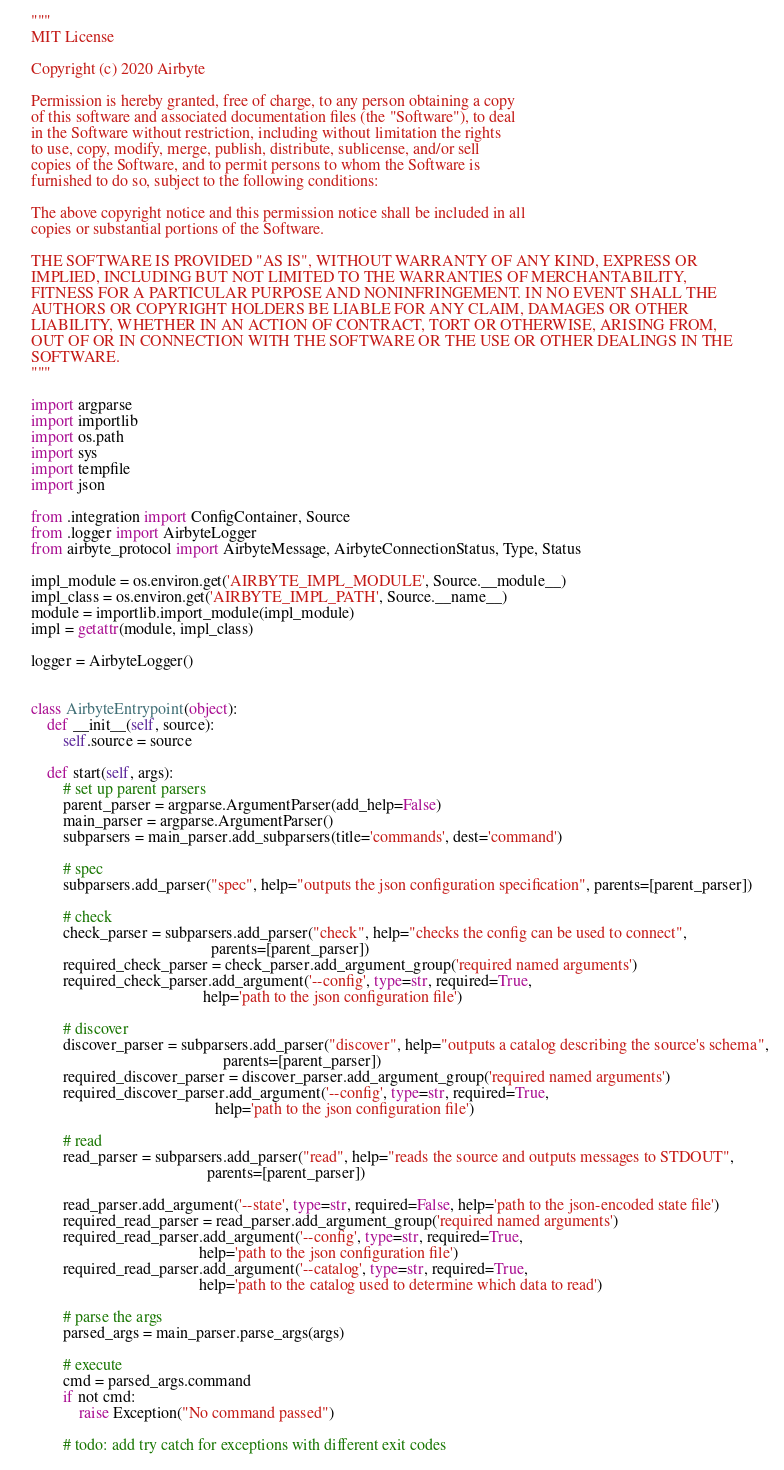<code> <loc_0><loc_0><loc_500><loc_500><_Python_>"""
MIT License

Copyright (c) 2020 Airbyte

Permission is hereby granted, free of charge, to any person obtaining a copy
of this software and associated documentation files (the "Software"), to deal
in the Software without restriction, including without limitation the rights
to use, copy, modify, merge, publish, distribute, sublicense, and/or sell
copies of the Software, and to permit persons to whom the Software is
furnished to do so, subject to the following conditions:

The above copyright notice and this permission notice shall be included in all
copies or substantial portions of the Software.

THE SOFTWARE IS PROVIDED "AS IS", WITHOUT WARRANTY OF ANY KIND, EXPRESS OR
IMPLIED, INCLUDING BUT NOT LIMITED TO THE WARRANTIES OF MERCHANTABILITY,
FITNESS FOR A PARTICULAR PURPOSE AND NONINFRINGEMENT. IN NO EVENT SHALL THE
AUTHORS OR COPYRIGHT HOLDERS BE LIABLE FOR ANY CLAIM, DAMAGES OR OTHER
LIABILITY, WHETHER IN AN ACTION OF CONTRACT, TORT OR OTHERWISE, ARISING FROM,
OUT OF OR IN CONNECTION WITH THE SOFTWARE OR THE USE OR OTHER DEALINGS IN THE
SOFTWARE.
"""

import argparse
import importlib
import os.path
import sys
import tempfile
import json

from .integration import ConfigContainer, Source
from .logger import AirbyteLogger
from airbyte_protocol import AirbyteMessage, AirbyteConnectionStatus, Type, Status

impl_module = os.environ.get('AIRBYTE_IMPL_MODULE', Source.__module__)
impl_class = os.environ.get('AIRBYTE_IMPL_PATH', Source.__name__)
module = importlib.import_module(impl_module)
impl = getattr(module, impl_class)

logger = AirbyteLogger()


class AirbyteEntrypoint(object):
    def __init__(self, source):
        self.source = source

    def start(self, args):
        # set up parent parsers
        parent_parser = argparse.ArgumentParser(add_help=False)
        main_parser = argparse.ArgumentParser()
        subparsers = main_parser.add_subparsers(title='commands', dest='command')

        # spec
        subparsers.add_parser("spec", help="outputs the json configuration specification", parents=[parent_parser])

        # check
        check_parser = subparsers.add_parser("check", help="checks the config can be used to connect",
                                             parents=[parent_parser])
        required_check_parser = check_parser.add_argument_group('required named arguments')
        required_check_parser.add_argument('--config', type=str, required=True,
                                           help='path to the json configuration file')

        # discover
        discover_parser = subparsers.add_parser("discover", help="outputs a catalog describing the source's schema",
                                                parents=[parent_parser])
        required_discover_parser = discover_parser.add_argument_group('required named arguments')
        required_discover_parser.add_argument('--config', type=str, required=True,
                                              help='path to the json configuration file')

        # read
        read_parser = subparsers.add_parser("read", help="reads the source and outputs messages to STDOUT",
                                            parents=[parent_parser])

        read_parser.add_argument('--state', type=str, required=False, help='path to the json-encoded state file')
        required_read_parser = read_parser.add_argument_group('required named arguments')
        required_read_parser.add_argument('--config', type=str, required=True,
                                          help='path to the json configuration file')
        required_read_parser.add_argument('--catalog', type=str, required=True,
                                          help='path to the catalog used to determine which data to read')

        # parse the args
        parsed_args = main_parser.parse_args(args)

        # execute
        cmd = parsed_args.command
        if not cmd:
            raise Exception("No command passed")

        # todo: add try catch for exceptions with different exit codes
</code> 